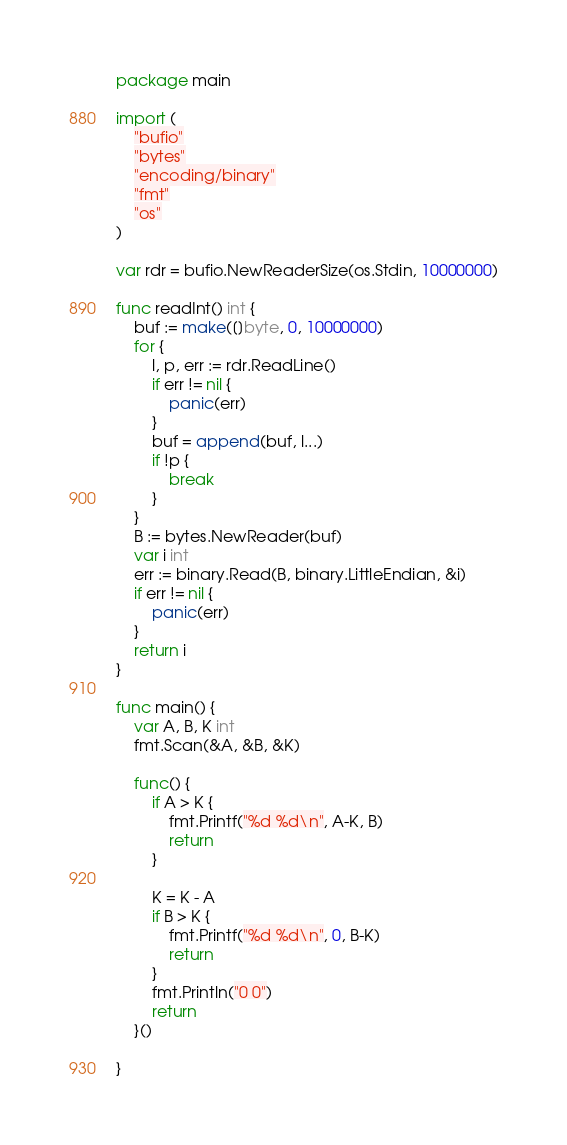Convert code to text. <code><loc_0><loc_0><loc_500><loc_500><_Go_>package main

import (
	"bufio"
	"bytes"
	"encoding/binary"
	"fmt"
	"os"
)

var rdr = bufio.NewReaderSize(os.Stdin, 10000000)

func readInt() int {
	buf := make([]byte, 0, 10000000)
	for {
		l, p, err := rdr.ReadLine()
		if err != nil {
			panic(err)
		}
		buf = append(buf, l...)
		if !p {
			break
		}
	}
	B := bytes.NewReader(buf)
	var i int
	err := binary.Read(B, binary.LittleEndian, &i)
	if err != nil {
		panic(err)
	}
	return i
}

func main() {
	var A, B, K int
	fmt.Scan(&A, &B, &K)

	func() {
		if A > K {
			fmt.Printf("%d %d\n", A-K, B)
			return
		}

		K = K - A
		if B > K {
			fmt.Printf("%d %d\n", 0, B-K)
			return
		}
		fmt.Println("0 0")
		return
	}()

}
</code> 